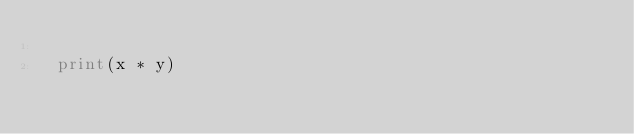<code> <loc_0><loc_0><loc_500><loc_500><_Python_>	
	print(x * y)</code> 